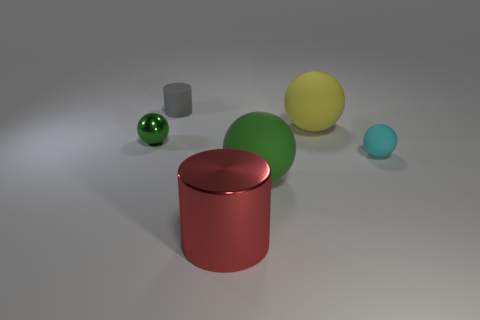Is the small cyan thing the same shape as the large red thing?
Provide a short and direct response. No. There is a metal thing right of the tiny gray object; how big is it?
Offer a terse response. Large. Is there a shiny cube of the same color as the small shiny sphere?
Your answer should be very brief. No. Do the shiny object that is to the left of the metallic cylinder and the big green object have the same size?
Ensure brevity in your answer.  No. What color is the tiny metallic thing?
Your answer should be very brief. Green. What is the color of the big thing behind the big rubber object that is in front of the tiny green metal ball?
Offer a terse response. Yellow. Are there any big green objects made of the same material as the tiny cyan sphere?
Ensure brevity in your answer.  Yes. There is a green sphere to the right of the tiny ball that is behind the tiny cyan rubber object; what is it made of?
Your answer should be very brief. Rubber. What number of large green matte objects have the same shape as the cyan matte object?
Keep it short and to the point. 1. What is the shape of the red metallic thing?
Ensure brevity in your answer.  Cylinder. 